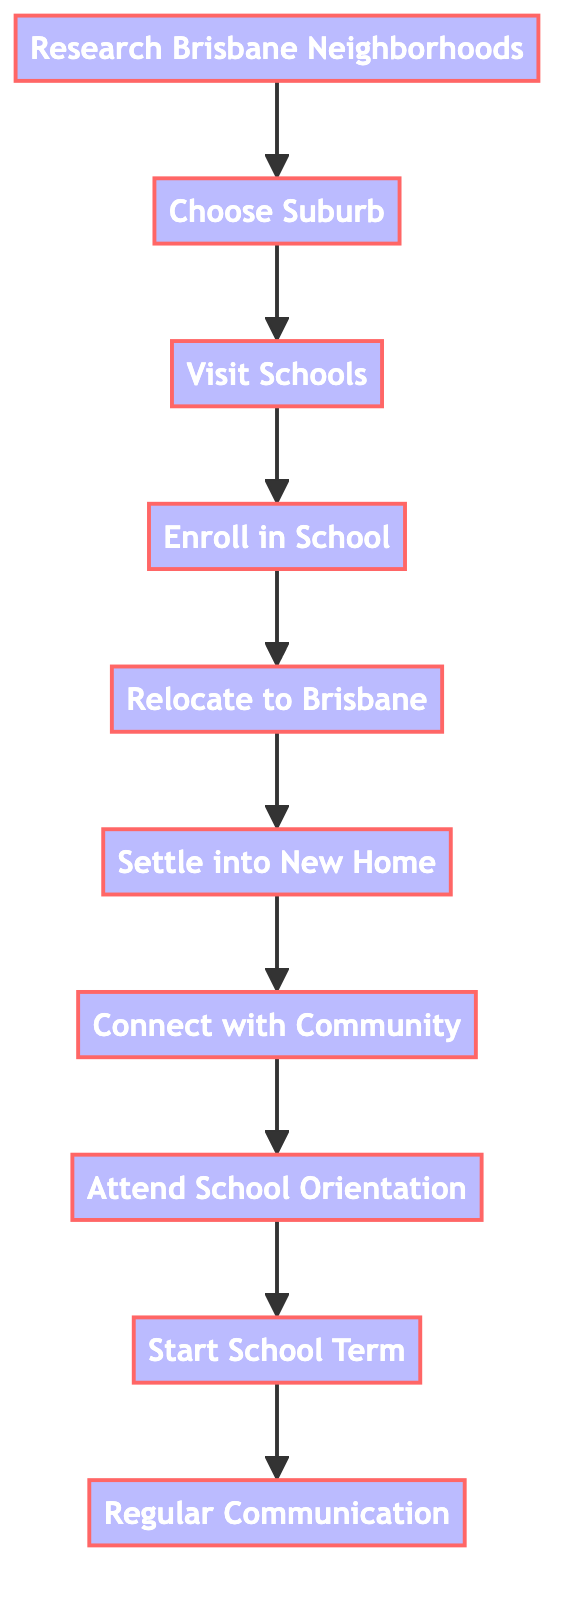What is the first step in the process? The first step is represented by node 1, which is "Research Brisbane Neighborhoods." This is established as the initial action before any other steps can take place.
Answer: Research Brisbane Neighborhoods How many total steps are there in the process? By counting the number of nodes represented in the diagram, we find there are a total of 10 distinct steps.
Answer: 10 What is the last step of the process? The last step is denoted by node 10, which is "Regular Communication." This indicates maintaining communication after starting school.
Answer: Regular Communication What follows after "Visit Schools"? The action that directly follows "Visit Schools," which is node 3, is "Enroll in School," represented by node 4. This shows the progression from visiting schools to enrolling in one.
Answer: Enroll in School Which step occurs immediately after "Settle into New Home"? Following "Settle into New Home," which is node 6, the next step is "Connect with Community," denoted by node 7. This indicates transitioning from settling in to engaging with the local community.
Answer: Connect with Community How many connections are present in the diagram? By examining the connections specified between nodes, there are a total of 9 connections that demonstrate the flow from one step to the next in the process.
Answer: 9 What is the relationship between "Choose Suburb" and "Visit Schools"? The connection between "Choose Suburb," represented by node 2, and "Visit Schools," represented by node 3, is a direct progression. Node 2 leads to node 3, indicating that choosing a suburb is a prerequisite for visiting schools.
Answer: Direct progression What step comes before "Attend School Orientation"? Before "Attend School Orientation," which is node 8, the preceding step is "Connect with Community," denoted by node 7. This indicates the need to engage with the community before attending orientation.
Answer: Connect with Community 